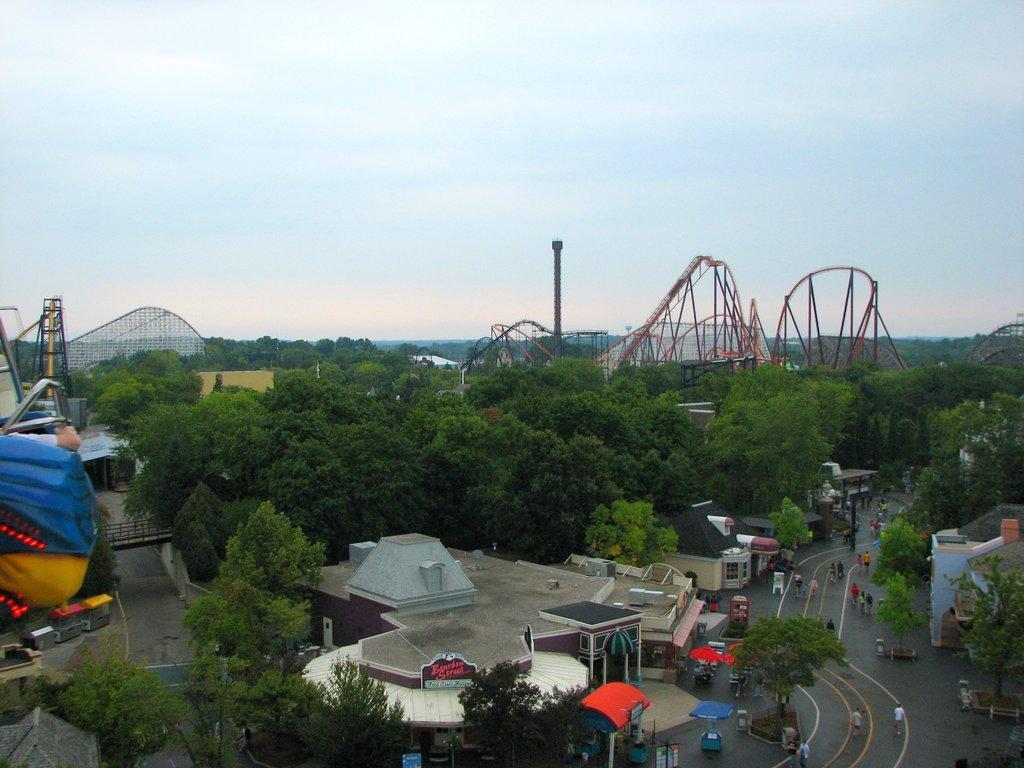Describe this image in one or two sentences. There are few people standing and walking on the road on the right side. In the background there are buildings,trees,amusing rides,poles,fence,hoardings,tents and clouds in the sky. 